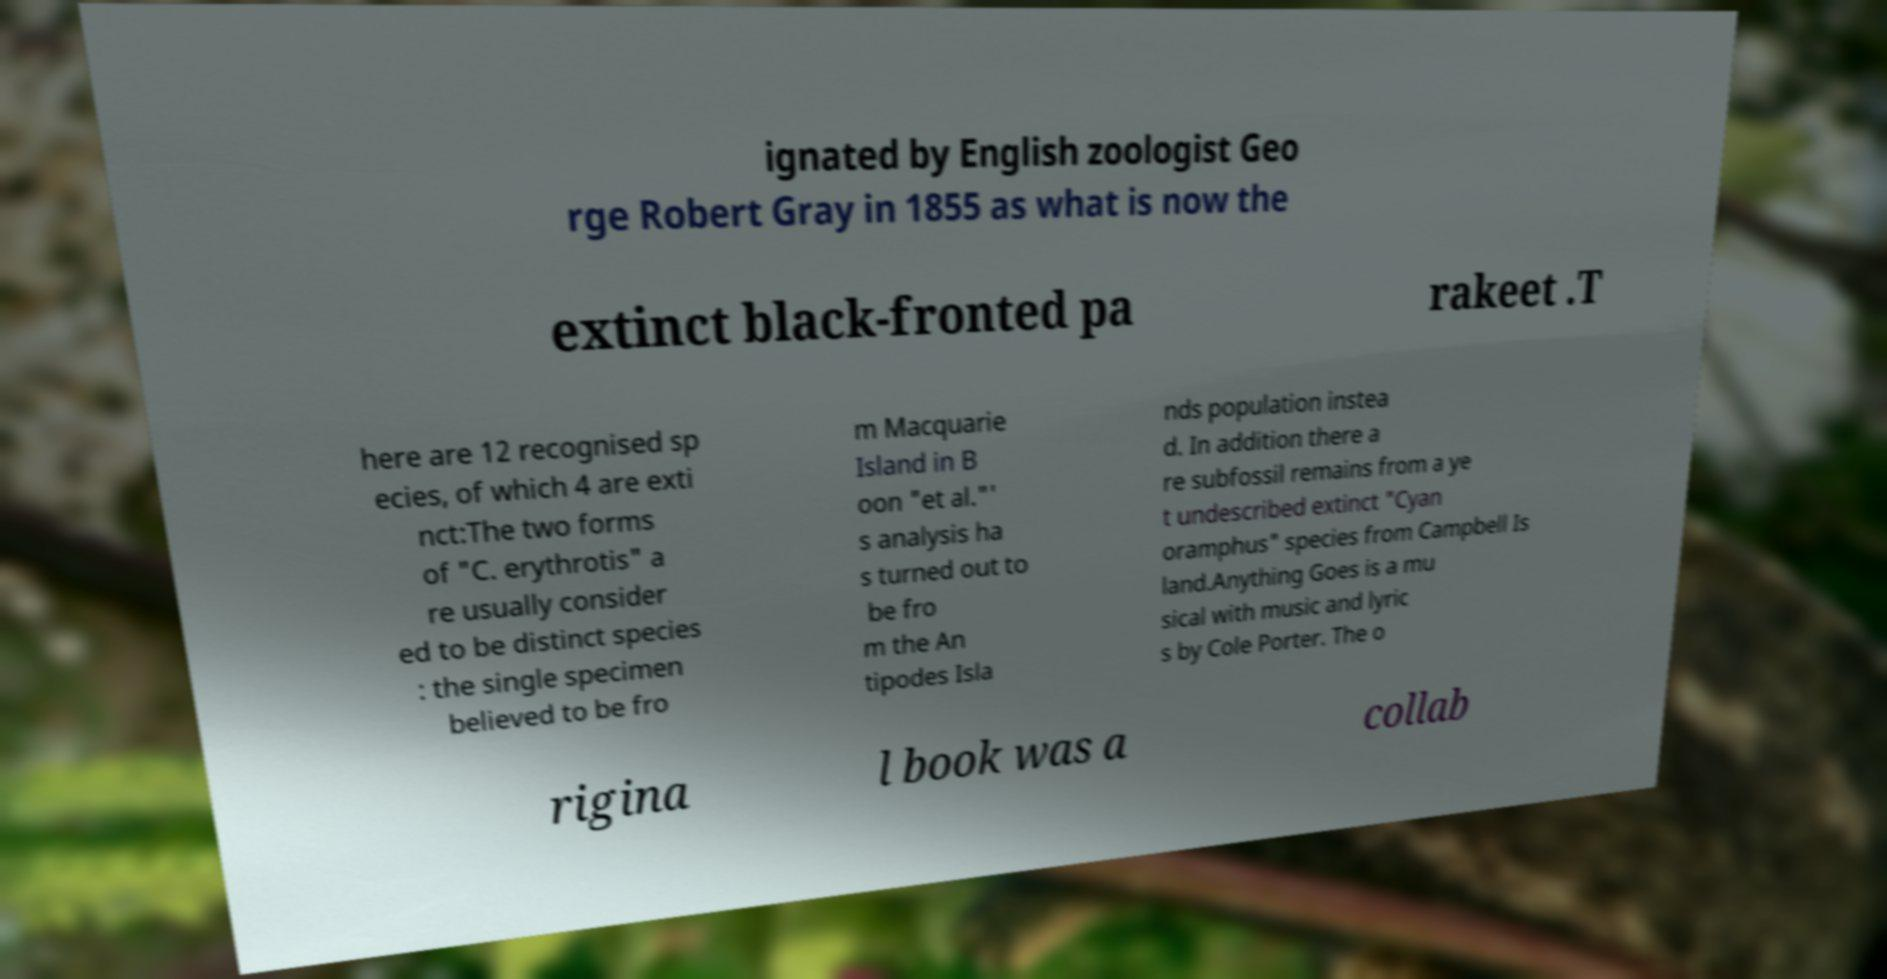For documentation purposes, I need the text within this image transcribed. Could you provide that? ignated by English zoologist Geo rge Robert Gray in 1855 as what is now the extinct black-fronted pa rakeet .T here are 12 recognised sp ecies, of which 4 are exti nct:The two forms of "C. erythrotis" a re usually consider ed to be distinct species : the single specimen believed to be fro m Macquarie Island in B oon "et al."' s analysis ha s turned out to be fro m the An tipodes Isla nds population instea d. In addition there a re subfossil remains from a ye t undescribed extinct "Cyan oramphus" species from Campbell Is land.Anything Goes is a mu sical with music and lyric s by Cole Porter. The o rigina l book was a collab 